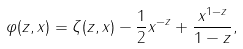Convert formula to latex. <formula><loc_0><loc_0><loc_500><loc_500>\varphi ( z , x ) = \zeta ( z , x ) - \frac { 1 } { 2 } x ^ { - z } + \frac { x ^ { 1 - z } } { 1 - z } ,</formula> 